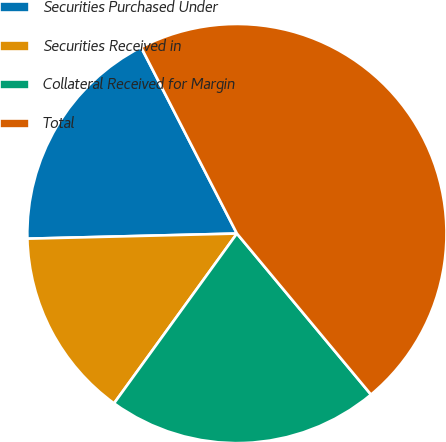Convert chart. <chart><loc_0><loc_0><loc_500><loc_500><pie_chart><fcel>Securities Purchased Under<fcel>Securities Received in<fcel>Collateral Received for Margin<fcel>Total<nl><fcel>17.83%<fcel>14.64%<fcel>21.02%<fcel>46.51%<nl></chart> 